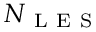<formula> <loc_0><loc_0><loc_500><loc_500>N _ { L E S }</formula> 